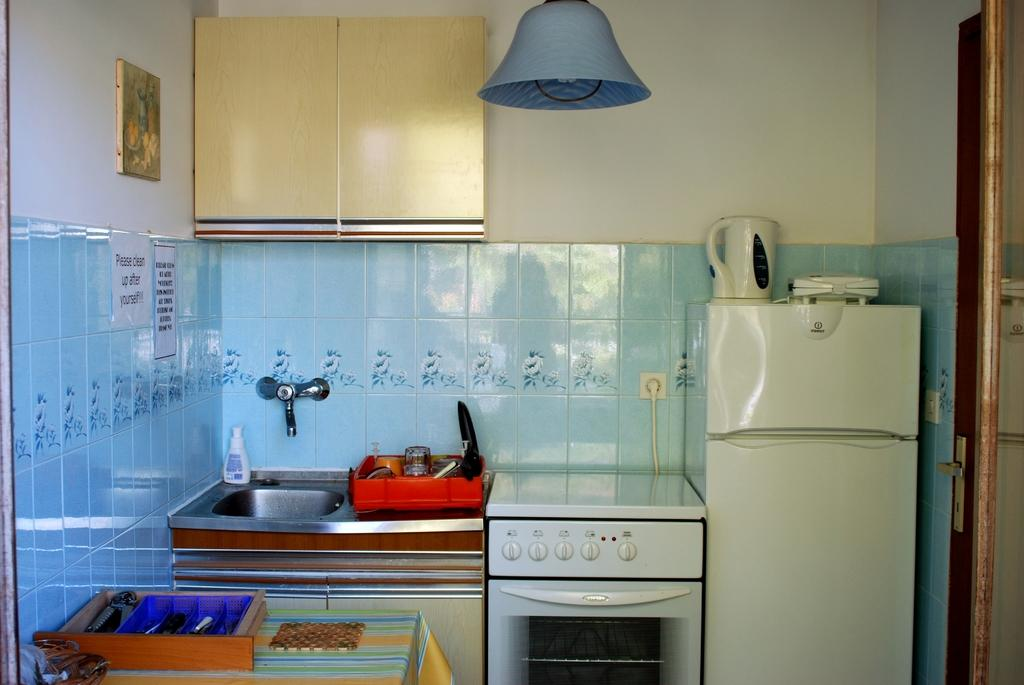<image>
Write a terse but informative summary of the picture. A kitchen with a Please clean up after yourself home made sign on the wall. 